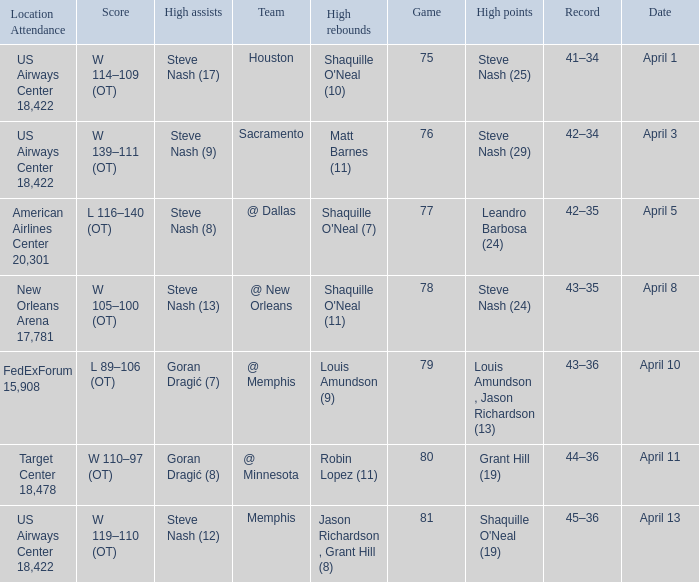Steve Nash (24) got high points for how many teams? 1.0. 